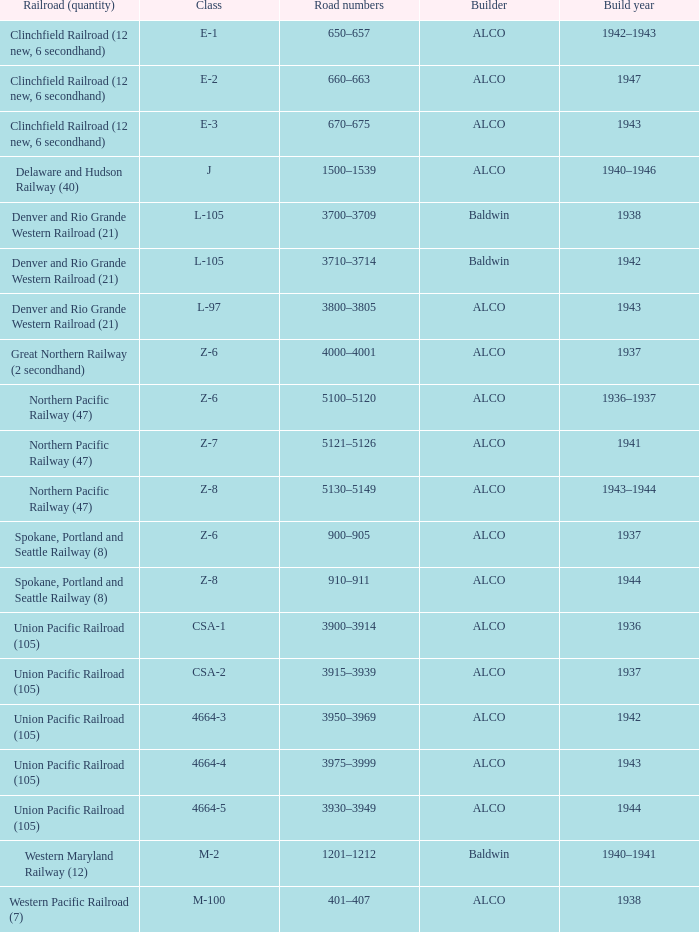What is the road numbers when the class is z-7? 5121–5126. 